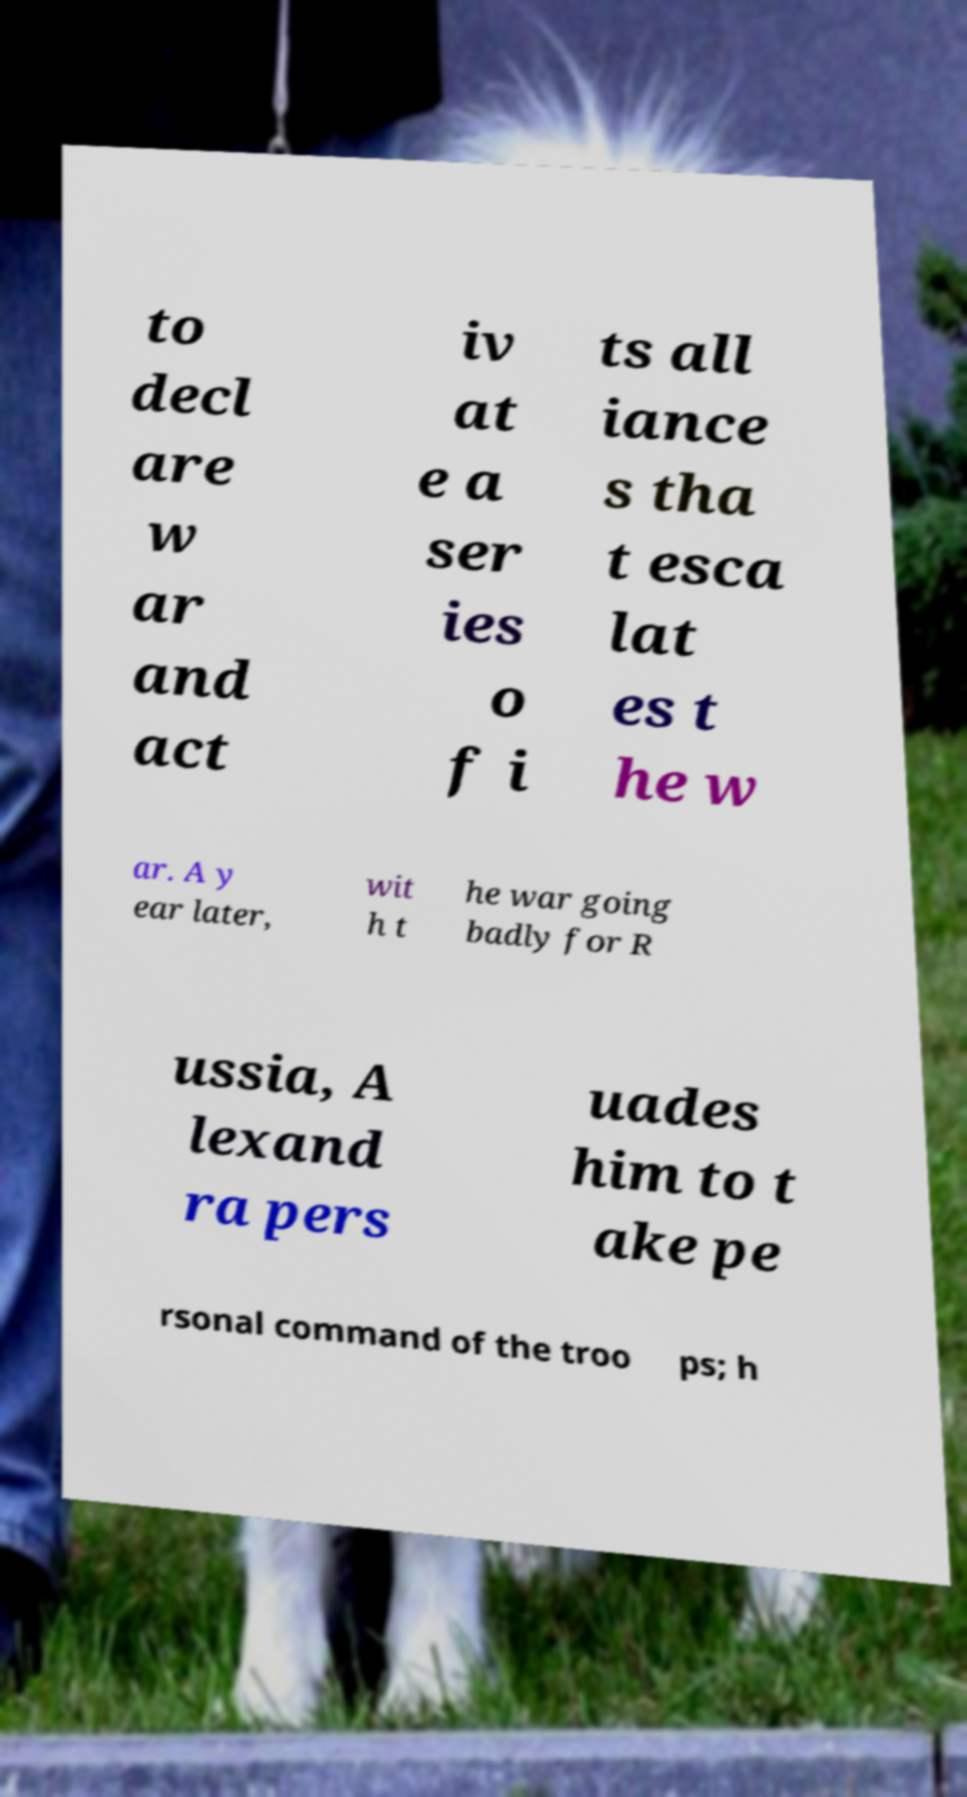For documentation purposes, I need the text within this image transcribed. Could you provide that? to decl are w ar and act iv at e a ser ies o f i ts all iance s tha t esca lat es t he w ar. A y ear later, wit h t he war going badly for R ussia, A lexand ra pers uades him to t ake pe rsonal command of the troo ps; h 